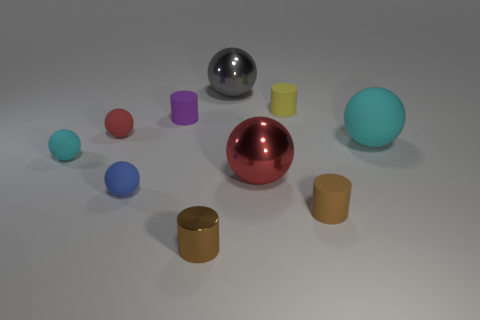Subtract 1 cylinders. How many cylinders are left? 3 Subtract all small blue spheres. How many spheres are left? 5 Subtract all red balls. How many balls are left? 4 Subtract all purple balls. Subtract all yellow cylinders. How many balls are left? 6 Subtract all cylinders. How many objects are left? 6 Subtract 1 yellow cylinders. How many objects are left? 9 Subtract all blue shiny blocks. Subtract all metallic objects. How many objects are left? 7 Add 5 small blue balls. How many small blue balls are left? 6 Add 8 big shiny spheres. How many big shiny spheres exist? 10 